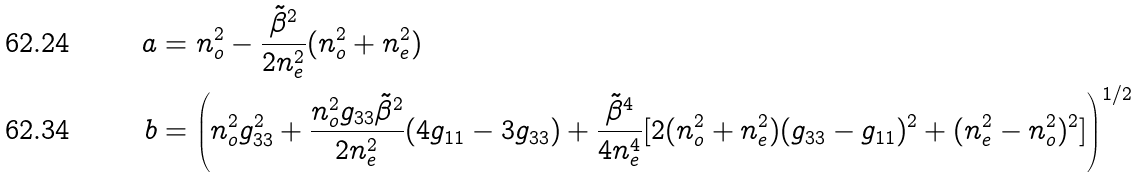Convert formula to latex. <formula><loc_0><loc_0><loc_500><loc_500>a & = n _ { o } ^ { 2 } - \frac { { \tilde { \beta } } ^ { 2 } } { 2 n _ { e } ^ { 2 } } ( n _ { o } ^ { 2 } + n _ { e } ^ { 2 } ) \\ b & = \left ( n _ { o } ^ { 2 } g _ { 3 3 } ^ { 2 } + \frac { n _ { o } ^ { 2 } g _ { 3 3 } { \tilde { \beta } } ^ { 2 } } { 2 n _ { e } ^ { 2 } } ( 4 g _ { 1 1 } - 3 g _ { 3 3 } ) + \frac { { \tilde { \beta } } ^ { 4 } } { 4 n _ { e } ^ { 4 } } [ 2 ( n _ { o } ^ { 2 } + n _ { e } ^ { 2 } ) ( g _ { 3 3 } - g _ { 1 1 } ) ^ { 2 } + ( n _ { e } ^ { 2 } - n _ { o } ^ { 2 } ) ^ { 2 } ] \right ) ^ { 1 / 2 }</formula> 